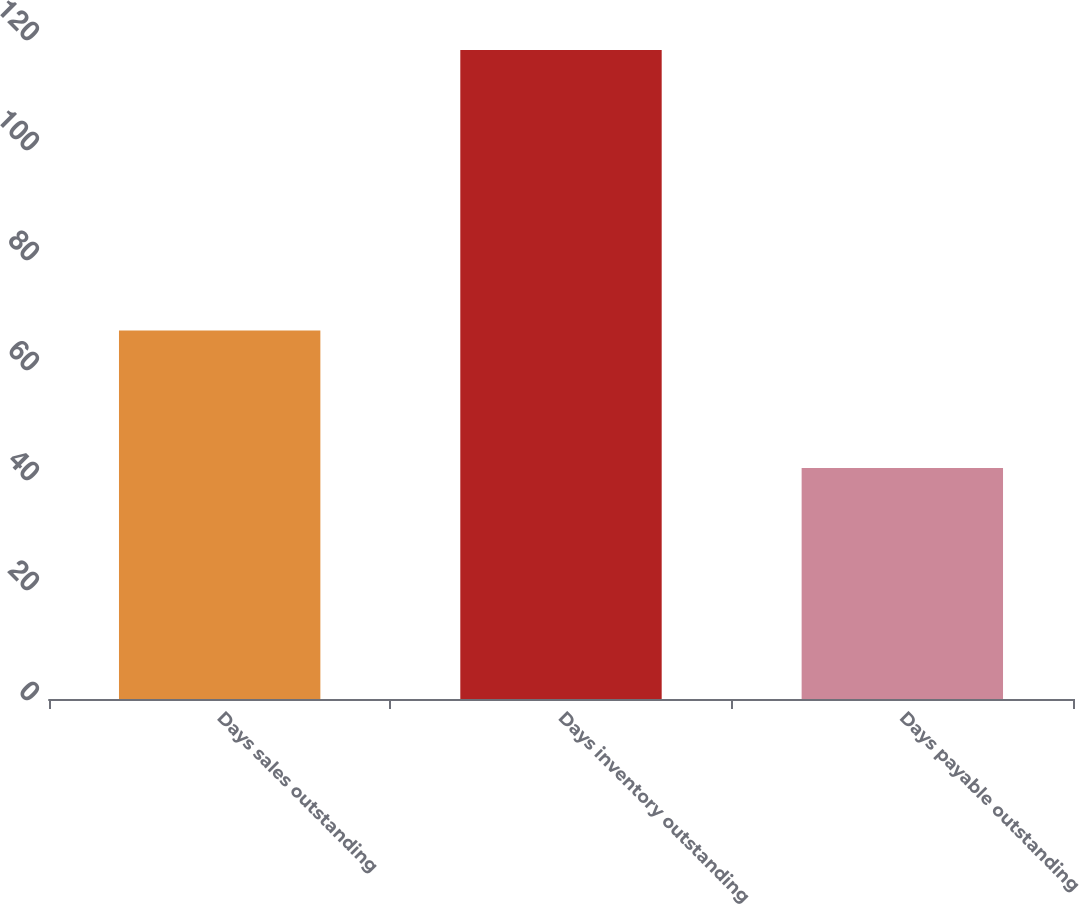<chart> <loc_0><loc_0><loc_500><loc_500><bar_chart><fcel>Days sales outstanding<fcel>Days inventory outstanding<fcel>Days payable outstanding<nl><fcel>67<fcel>118<fcel>42<nl></chart> 